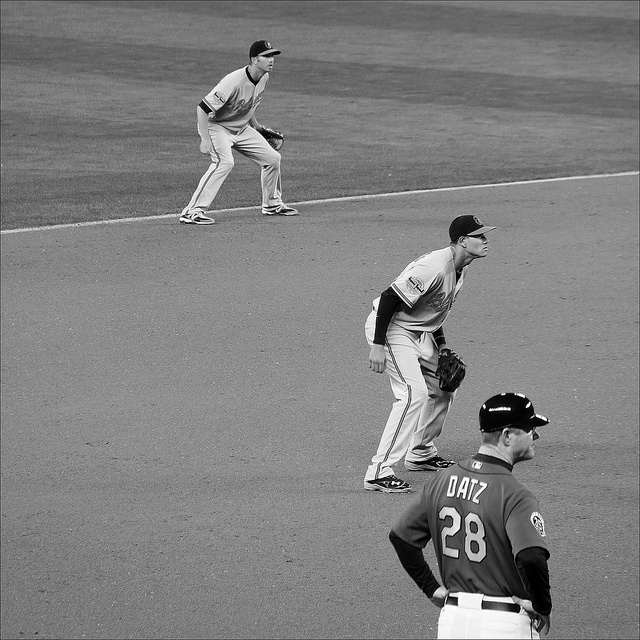Describe the objects in this image and their specific colors. I can see people in black, gray, darkgray, and white tones, people in black, lightgray, darkgray, and gray tones, people in black, darkgray, lightgray, and gray tones, baseball glove in black, gray, and lightgray tones, and baseball glove in black, gray, darkgray, and lightgray tones in this image. 